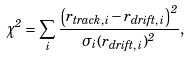Convert formula to latex. <formula><loc_0><loc_0><loc_500><loc_500>\chi ^ { 2 } = \sum _ { i } \frac { \left ( r _ { t r a c k , \, i } - r _ { d r i f t , \, i } \right ) ^ { 2 } } { \sigma _ { i } ( r _ { d r i f t , \, i } ) ^ { 2 } } ,</formula> 